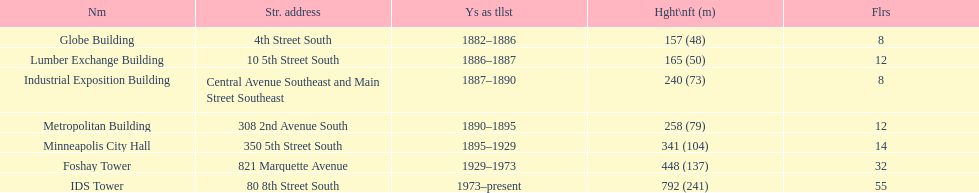What was the first building named as the tallest? Globe Building. 